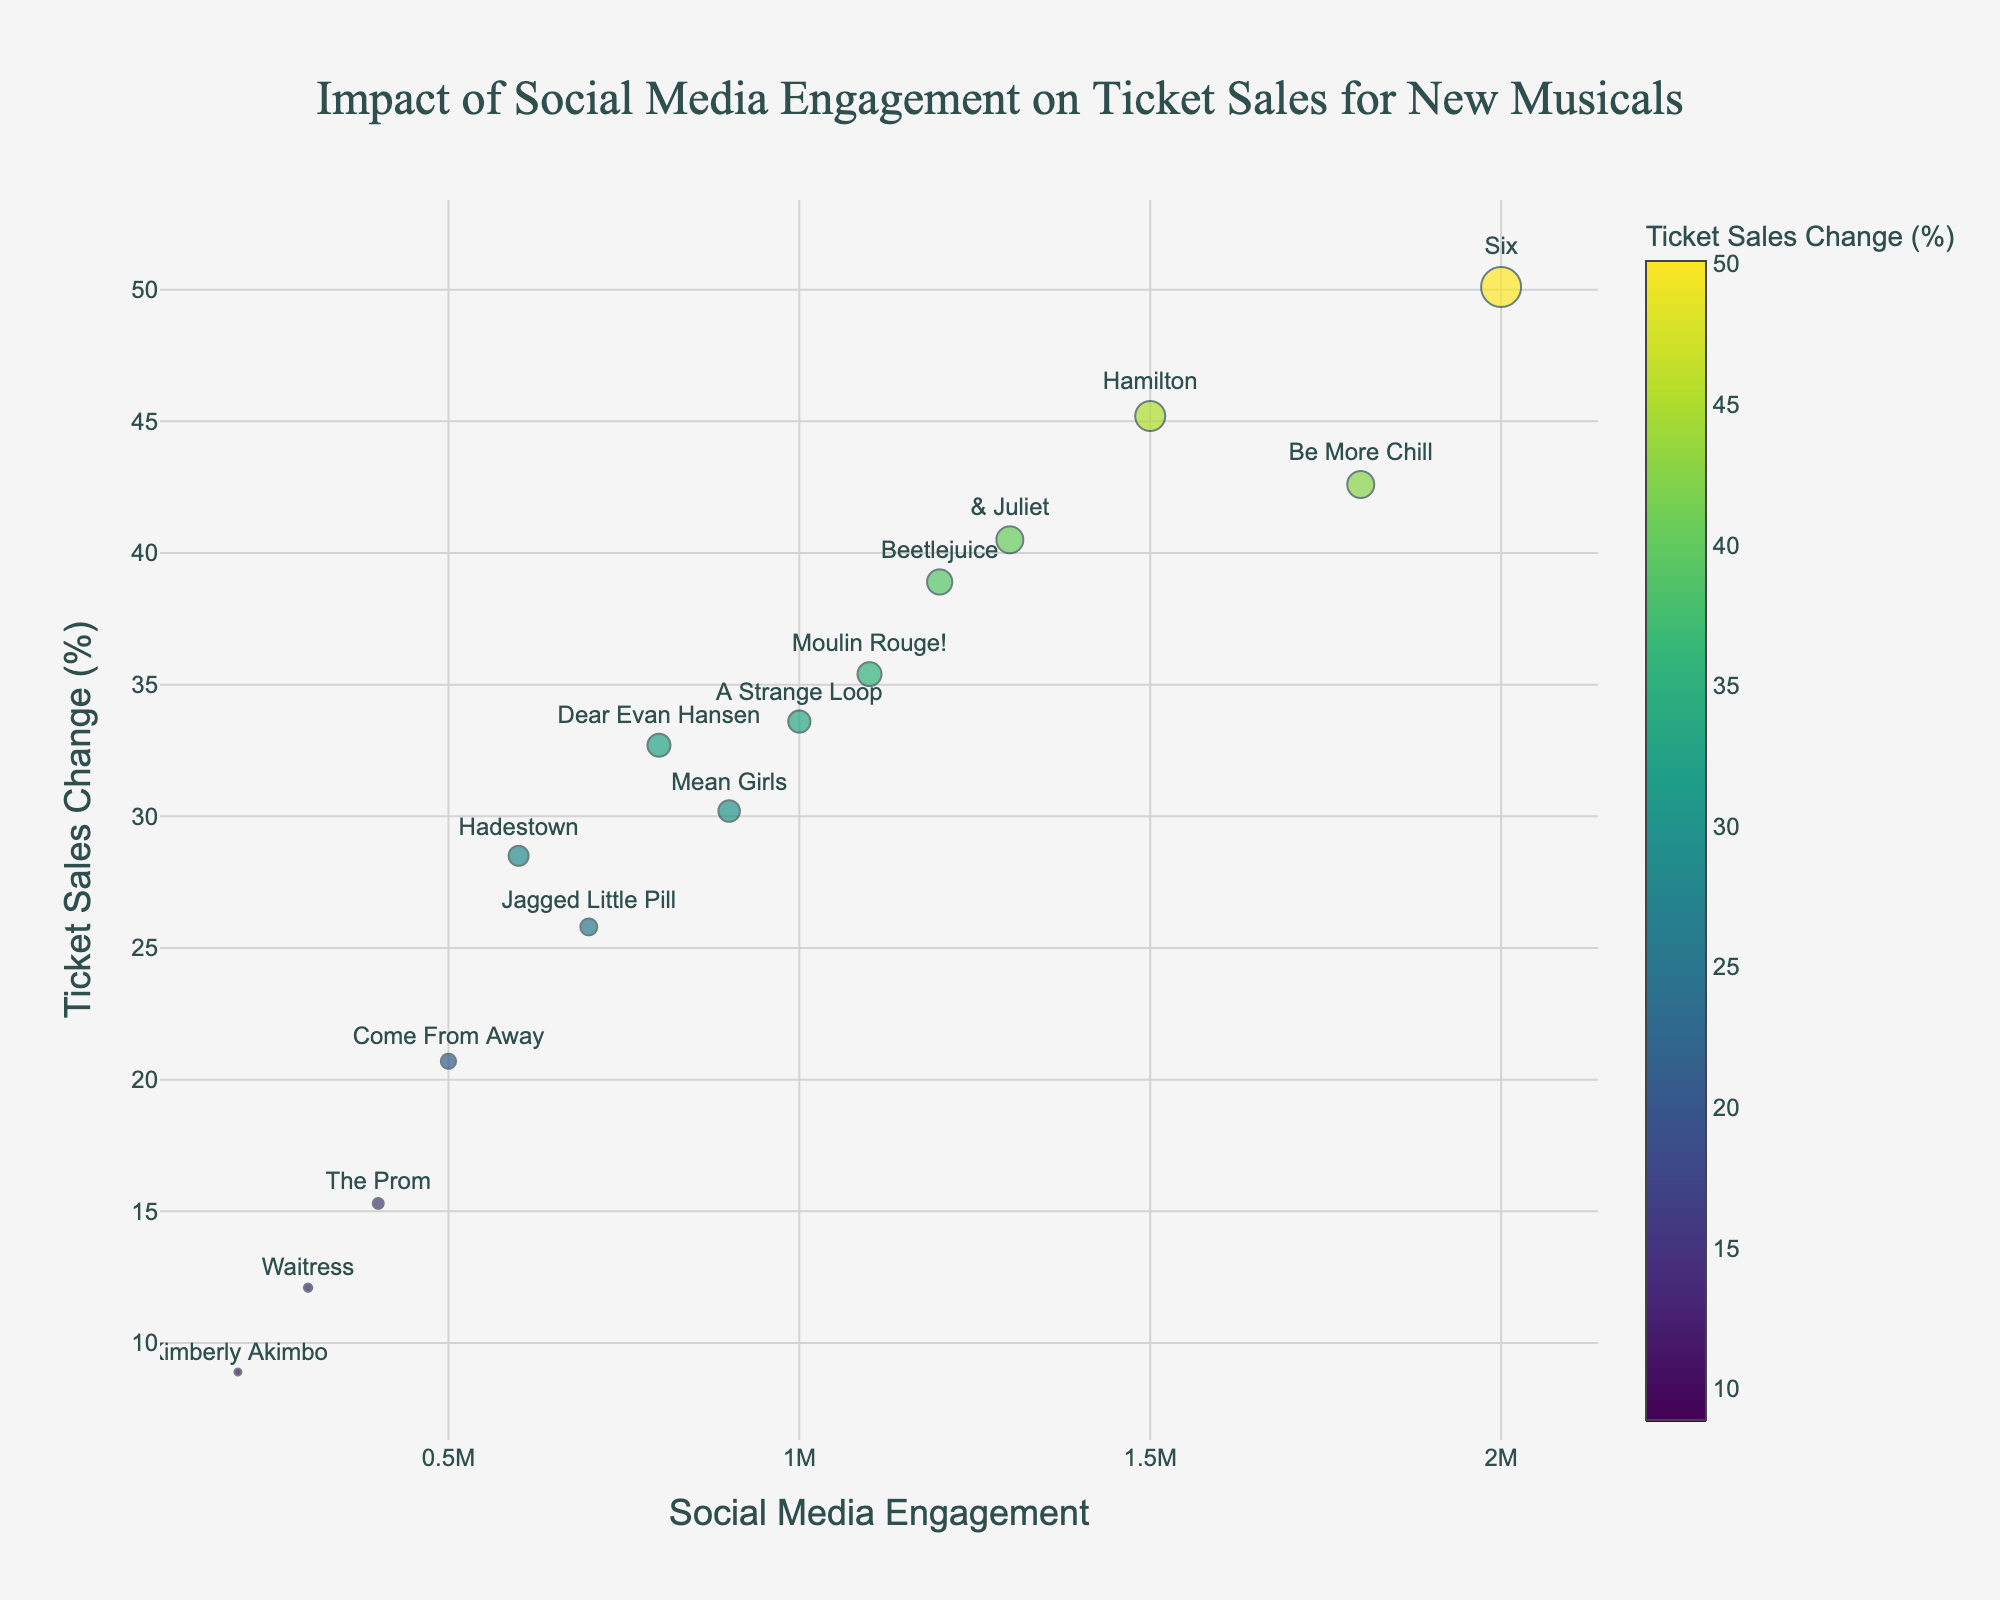what is the title of the plot? The title is displayed at the top center of the plot, reading "Impact of Social Media Engagement on Ticket Sales for New Musicals"
Answer: Impact of Social Media Engagement on Ticket Sales for New Musicals how is the p-value represented in the plot? The p-value is represented by the size of the markers. The lower the p-value, the larger the marker size.
Answer: marker size Which musical shows the highest increase in ticket sales? "Six" is positioned the highest on the y-axis, indicating the highest ticket sales change.
Answer: Six Which musical has the lowest social media engagement but still a noticeable change in ticket sales? "Kimberly Akimbo" lies farthest to the left on the x-axis with noticeable ticket sales change.
Answer: Kimberly Akimbo What is the color scale used in the plot and what does it represent? The plot uses the Viridis color scale to represent Ticket Sales Change (%). Darker colors correspond to lower ticket sales changes, and brighter colors depict higher changes.
Answer: Viridis Which musicals have a ticket sales change greater than 40%? Point your eyes to musicals above the 40% mark on the y-axis. They are "Be More Chill," "Six," and "& Juliet."
Answer: Be More Chill, Six, & Juliet What can be inferred about musicals with high social media engagement? Musicals like "Hamilton," "Six," and "Be More Chill" with high social media engagement (right side on x-axis) generally show significant ticket sales changes. This indicates a positive correlation between social media engagement and ticket sales.
Answer: Positive correlation Which musical has the lowest statistically significant p-value? Check the smallest marker size; it is for "Six," indicating the lowest p-value of 0.0001.
Answer: Six How many musicals have both high social media engagement (over 1 million) and substantial ticket sales increase (over 30%)? Count the markers on the upper-right quadrant of the plot: "Hamilton," "Six," "Be More Chill," "Beetlejuice," and "& Juliet," making 5 in total.
Answer: 5 